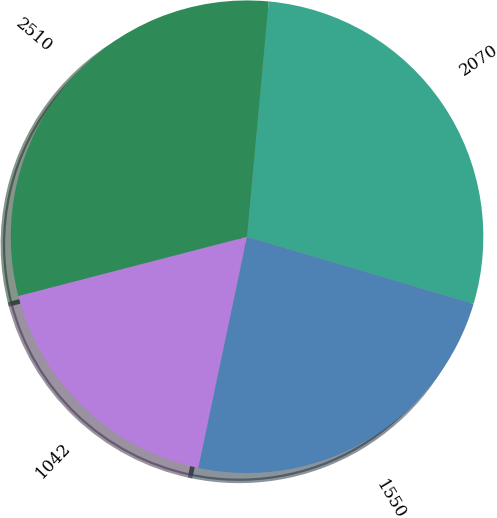Convert chart to OTSL. <chart><loc_0><loc_0><loc_500><loc_500><pie_chart><fcel>1042<fcel>1550<fcel>2070<fcel>2510<nl><fcel>17.66%<fcel>23.72%<fcel>28.12%<fcel>30.5%<nl></chart> 